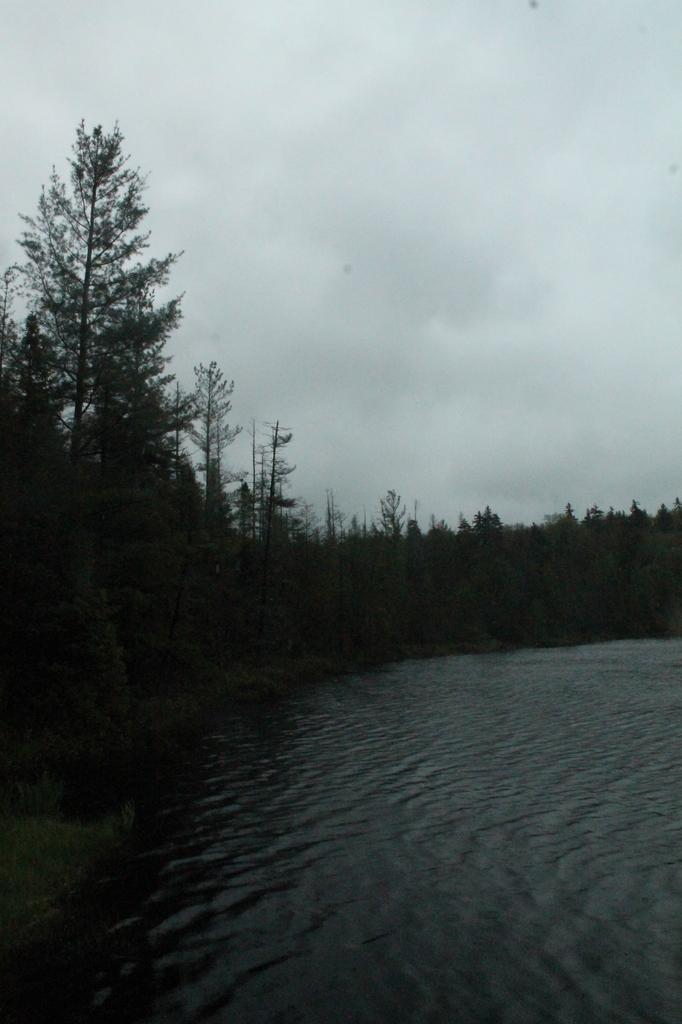Could you give a brief overview of what you see in this image? In this picture we can see water and trees and we can see sky in the background. 